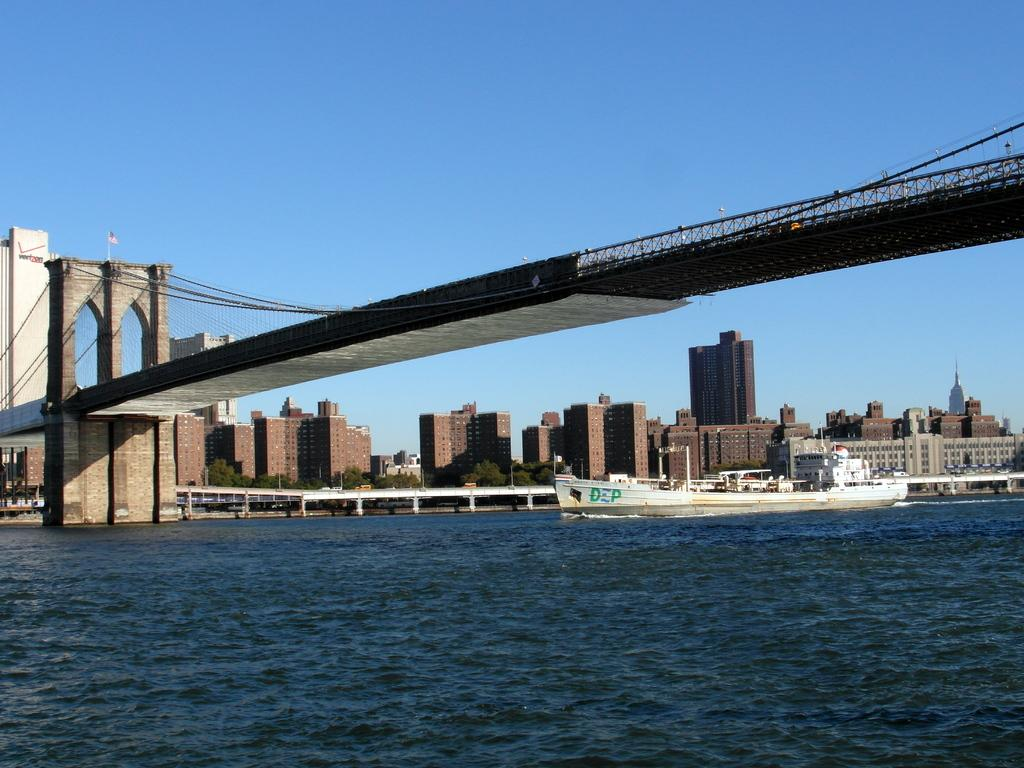What type of structures can be seen in the image? There are buildings in the image. What is located in the water in the image? There is a ship in the water in the image. What connects the two sides of the water in the image? There is a bridge in the image. What color is the sky in the image? The sky is blue in the image. What type of marble is used to decorate the buildings in the image? There is no mention of marble in the image, as the focus is on the buildings, ship, bridge, and blue sky. What effect does the ship have on the buildings in the image? The image does not depict any interaction between the ship and the buildings, so it is not possible to determine any effect. 